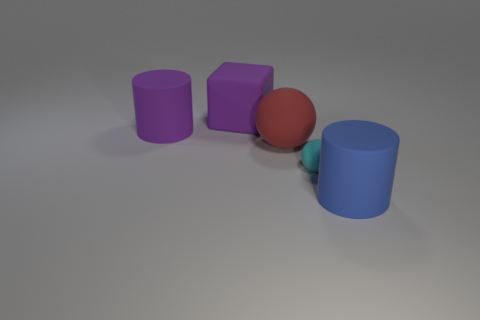Is there anything else that has the same size as the cyan matte thing?
Provide a succinct answer. No. There is a red rubber thing; is its size the same as the cylinder that is on the left side of the large blue thing?
Offer a very short reply. Yes. There is a big purple rubber thing right of the purple object that is in front of the big purple cube; is there a matte ball that is in front of it?
Your answer should be compact. Yes. There is a thing that is in front of the small object; what is its material?
Ensure brevity in your answer.  Rubber. Does the blue matte thing have the same size as the rubber block?
Offer a very short reply. Yes. The object that is both to the left of the large blue object and in front of the red matte object is what color?
Offer a terse response. Cyan. What is the shape of the large blue object that is made of the same material as the block?
Offer a very short reply. Cylinder. How many large objects are behind the cyan object and on the right side of the big purple matte cylinder?
Provide a short and direct response. 2. Are there any large red objects on the right side of the blue object?
Ensure brevity in your answer.  No. There is a big red matte thing that is left of the small object; is it the same shape as the rubber thing that is on the right side of the tiny object?
Provide a short and direct response. No. 